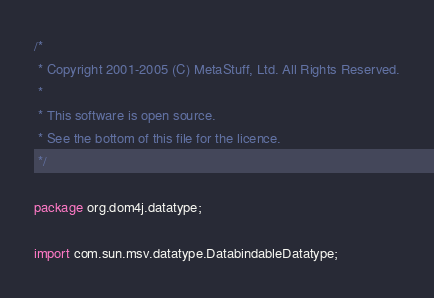Convert code to text. <code><loc_0><loc_0><loc_500><loc_500><_Java_>/*
 * Copyright 2001-2005 (C) MetaStuff, Ltd. All Rights Reserved.
 *
 * This software is open source.
 * See the bottom of this file for the licence.
 */

package org.dom4j.datatype;

import com.sun.msv.datatype.DatabindableDatatype;</code> 